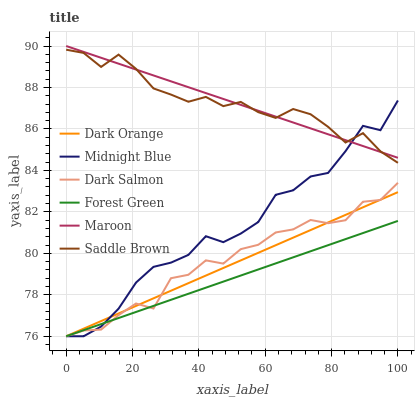Does Forest Green have the minimum area under the curve?
Answer yes or no. Yes. Does Maroon have the maximum area under the curve?
Answer yes or no. Yes. Does Midnight Blue have the minimum area under the curve?
Answer yes or no. No. Does Midnight Blue have the maximum area under the curve?
Answer yes or no. No. Is Maroon the smoothest?
Answer yes or no. Yes. Is Midnight Blue the roughest?
Answer yes or no. Yes. Is Dark Salmon the smoothest?
Answer yes or no. No. Is Dark Salmon the roughest?
Answer yes or no. No. Does Dark Orange have the lowest value?
Answer yes or no. Yes. Does Maroon have the lowest value?
Answer yes or no. No. Does Maroon have the highest value?
Answer yes or no. Yes. Does Midnight Blue have the highest value?
Answer yes or no. No. Is Dark Orange less than Saddle Brown?
Answer yes or no. Yes. Is Maroon greater than Forest Green?
Answer yes or no. Yes. Does Dark Salmon intersect Midnight Blue?
Answer yes or no. Yes. Is Dark Salmon less than Midnight Blue?
Answer yes or no. No. Is Dark Salmon greater than Midnight Blue?
Answer yes or no. No. Does Dark Orange intersect Saddle Brown?
Answer yes or no. No. 